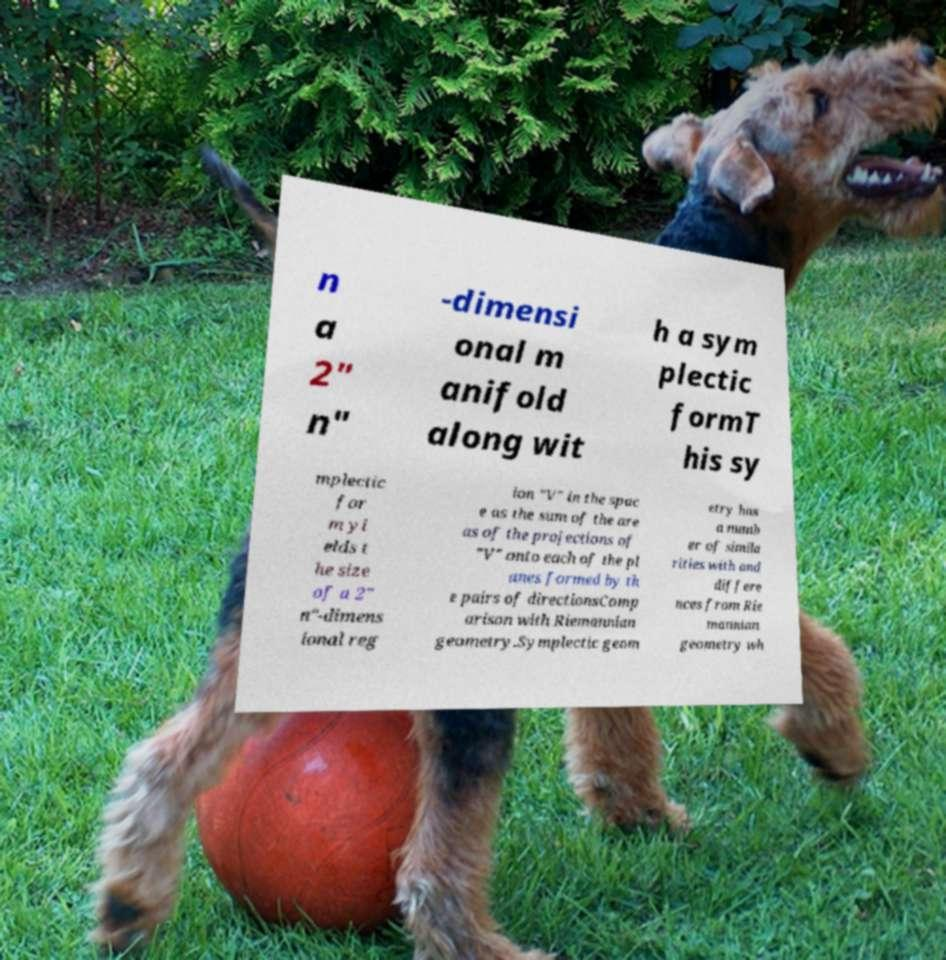Please read and relay the text visible in this image. What does it say? n a 2" n" -dimensi onal m anifold along wit h a sym plectic formT his sy mplectic for m yi elds t he size of a 2" n"-dimens ional reg ion "V" in the spac e as the sum of the are as of the projections of "V" onto each of the pl anes formed by th e pairs of directionsComp arison with Riemannian geometry.Symplectic geom etry has a numb er of simila rities with and differe nces from Rie mannian geometry wh 